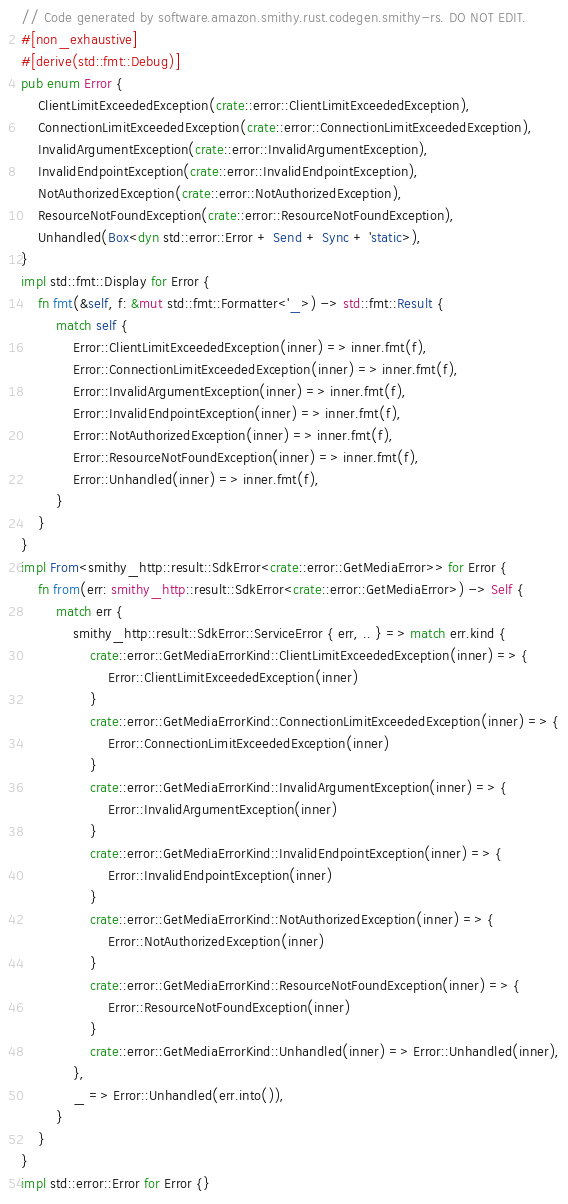Convert code to text. <code><loc_0><loc_0><loc_500><loc_500><_Rust_>// Code generated by software.amazon.smithy.rust.codegen.smithy-rs. DO NOT EDIT.
#[non_exhaustive]
#[derive(std::fmt::Debug)]
pub enum Error {
    ClientLimitExceededException(crate::error::ClientLimitExceededException),
    ConnectionLimitExceededException(crate::error::ConnectionLimitExceededException),
    InvalidArgumentException(crate::error::InvalidArgumentException),
    InvalidEndpointException(crate::error::InvalidEndpointException),
    NotAuthorizedException(crate::error::NotAuthorizedException),
    ResourceNotFoundException(crate::error::ResourceNotFoundException),
    Unhandled(Box<dyn std::error::Error + Send + Sync + 'static>),
}
impl std::fmt::Display for Error {
    fn fmt(&self, f: &mut std::fmt::Formatter<'_>) -> std::fmt::Result {
        match self {
            Error::ClientLimitExceededException(inner) => inner.fmt(f),
            Error::ConnectionLimitExceededException(inner) => inner.fmt(f),
            Error::InvalidArgumentException(inner) => inner.fmt(f),
            Error::InvalidEndpointException(inner) => inner.fmt(f),
            Error::NotAuthorizedException(inner) => inner.fmt(f),
            Error::ResourceNotFoundException(inner) => inner.fmt(f),
            Error::Unhandled(inner) => inner.fmt(f),
        }
    }
}
impl From<smithy_http::result::SdkError<crate::error::GetMediaError>> for Error {
    fn from(err: smithy_http::result::SdkError<crate::error::GetMediaError>) -> Self {
        match err {
            smithy_http::result::SdkError::ServiceError { err, .. } => match err.kind {
                crate::error::GetMediaErrorKind::ClientLimitExceededException(inner) => {
                    Error::ClientLimitExceededException(inner)
                }
                crate::error::GetMediaErrorKind::ConnectionLimitExceededException(inner) => {
                    Error::ConnectionLimitExceededException(inner)
                }
                crate::error::GetMediaErrorKind::InvalidArgumentException(inner) => {
                    Error::InvalidArgumentException(inner)
                }
                crate::error::GetMediaErrorKind::InvalidEndpointException(inner) => {
                    Error::InvalidEndpointException(inner)
                }
                crate::error::GetMediaErrorKind::NotAuthorizedException(inner) => {
                    Error::NotAuthorizedException(inner)
                }
                crate::error::GetMediaErrorKind::ResourceNotFoundException(inner) => {
                    Error::ResourceNotFoundException(inner)
                }
                crate::error::GetMediaErrorKind::Unhandled(inner) => Error::Unhandled(inner),
            },
            _ => Error::Unhandled(err.into()),
        }
    }
}
impl std::error::Error for Error {}
</code> 